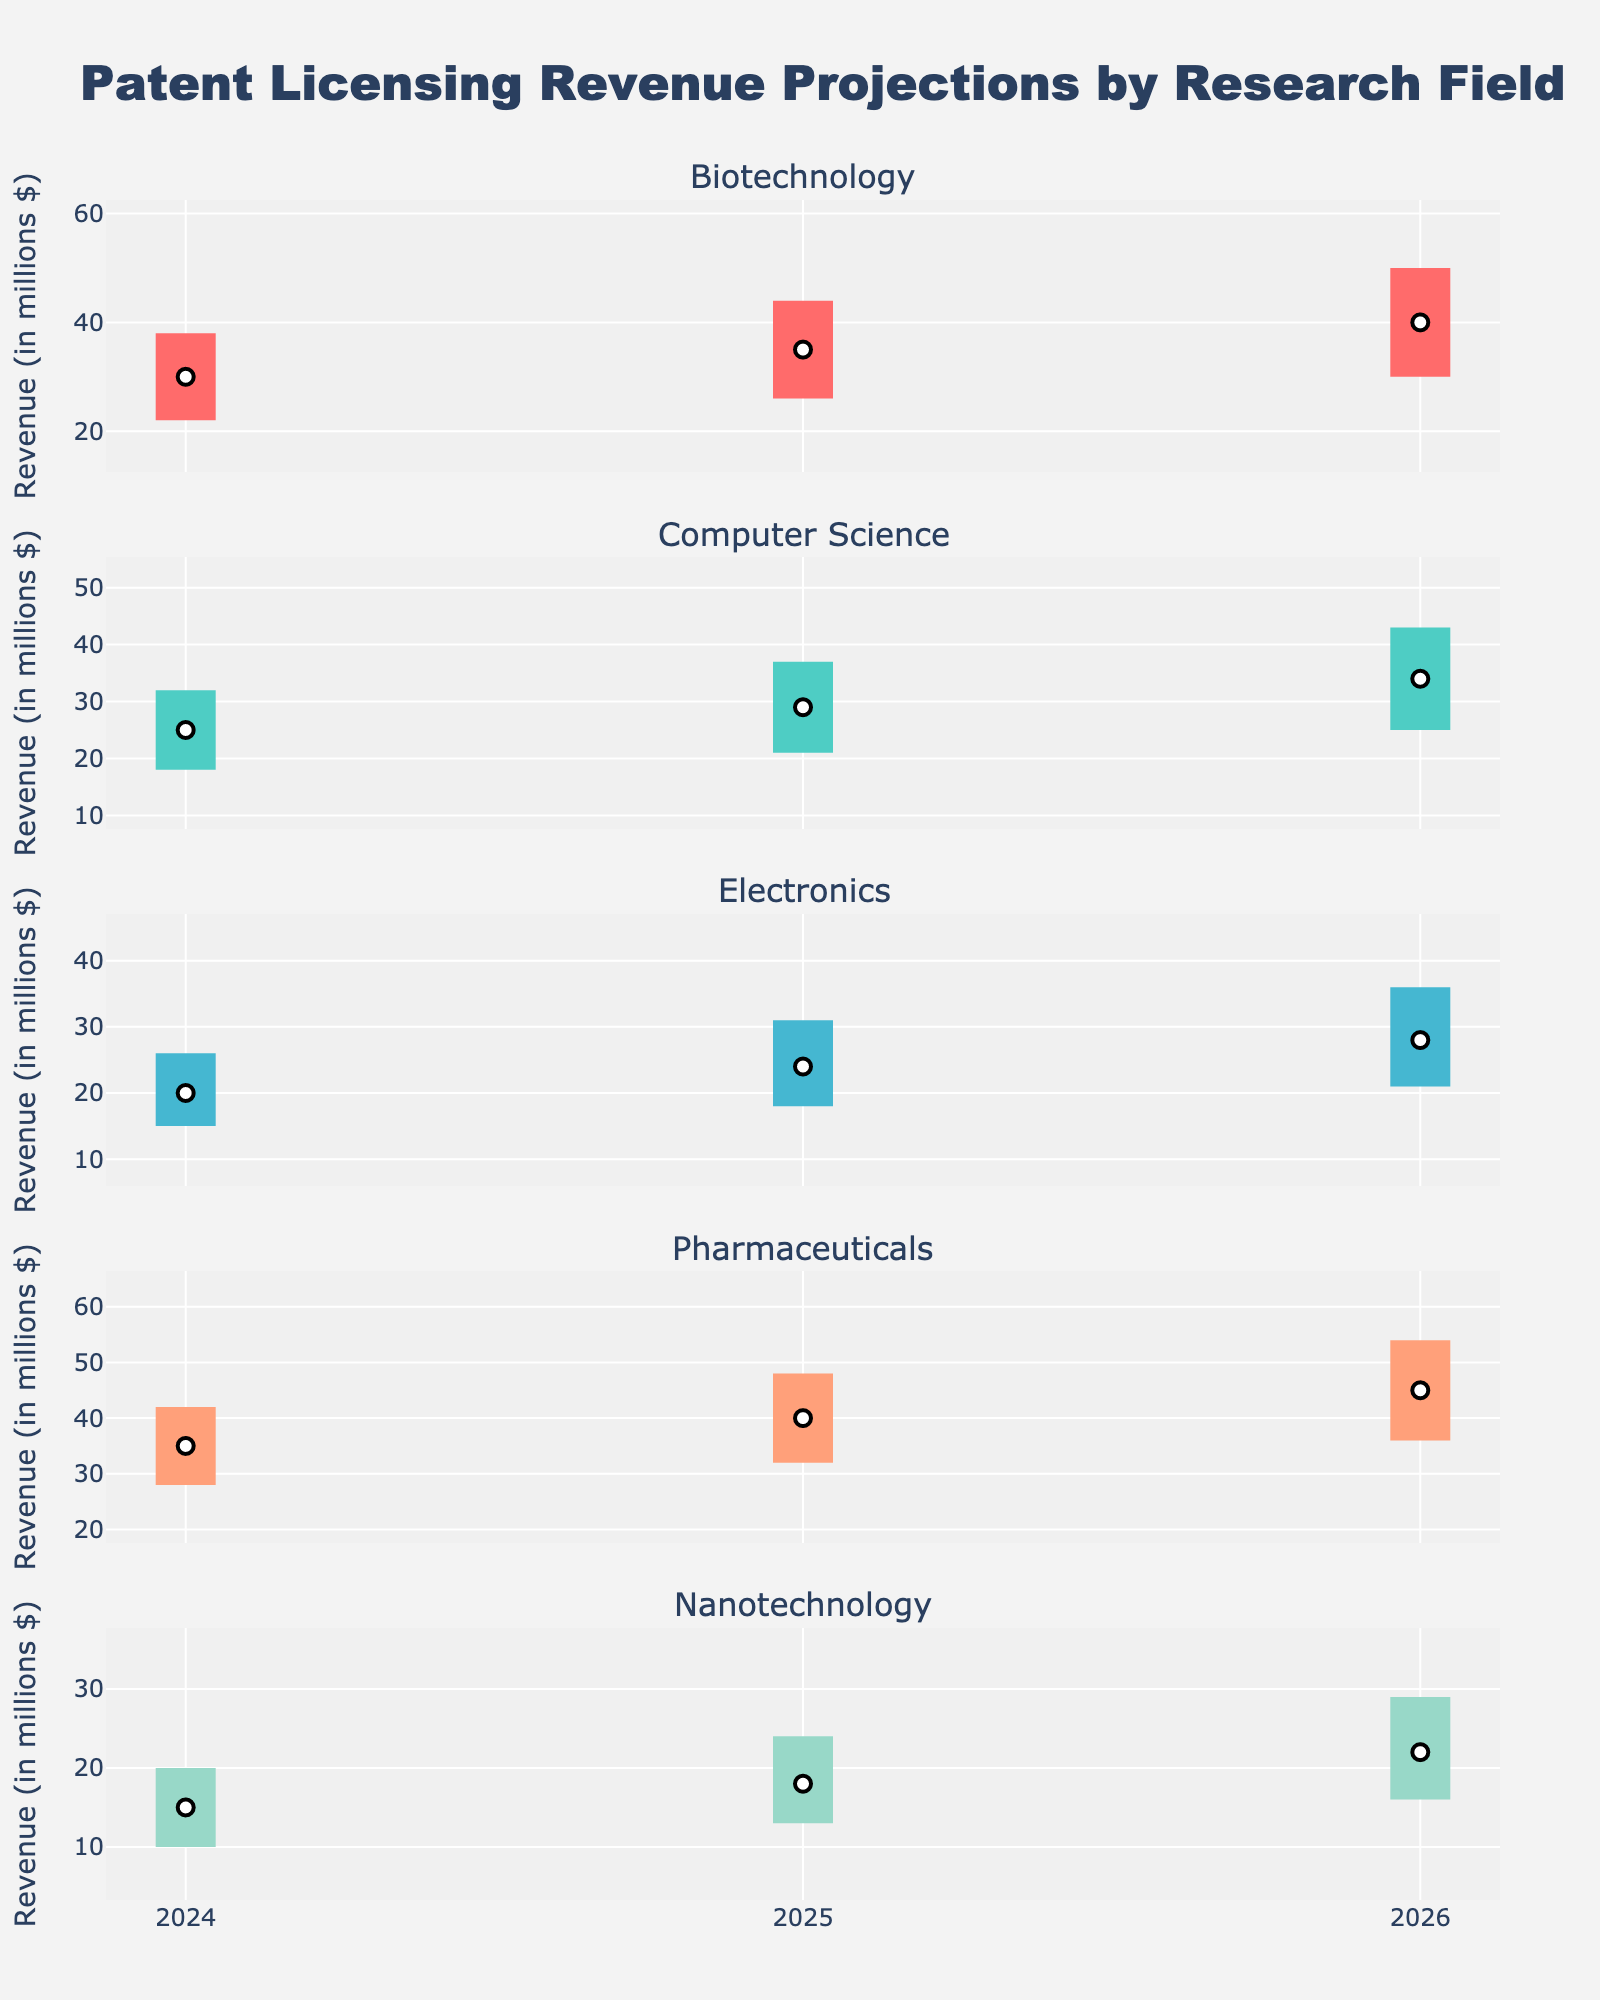What is the title of the chart? The title of the chart is located at the top and reads "Patent Licensing Revenue Projections by Research Field".
Answer: Patent Licensing Revenue Projections by Research Field Which field shows the highest median revenue projection for 2026? Look at the 2026 projections for each field. The median revenue projection is marked by a white marker in each subplot. Identify the highest marker among Biotechnology, Computer Science, Electronics, Pharmaceuticals, and Nanotechnology.
Answer: Pharmaceuticals What is the range of expected revenue for Biotechnology in 2025? For each year, revenue ranges are shown by colored areas. For 2025 in Biotechnology, look at the start and end of the colored area (between P25 and P75) in the Biotechnology subplot. This represents the range.
Answer: 26 to 44 million Which research field shows the smallest difference between the 10th and 90th percentiles in 2024? Examine the difference between the P10 and P90 markers for each field in 2024. Subtract P10 values from P90 values for Biotechnology, Computer Science, Electronics, Pharmaceuticals, and Nanotechnology. Identify the smallest difference.
Answer: Nanotechnology What is the average median revenue projection for all fields in 2025? Identify the median values for each field in 2025 from the white markers: Biotechnology (35), Computer Science (29), Electronics (24), Pharmaceuticals (40), and Nanotechnology (18). Sum these values and divide by the number of fields.
Answer: 29.2 million Which field shows the fastest growth in median revenue projections from 2024 to 2026? Compare the increase in median projections (white markers) from 2024 to 2026 for each field. Calculate the difference for each: Biotechnology (40-30), Computer Science (34-25), Electronics (28-20), Pharmaceuticals (45-35), Nanotechnology (22-15). Identify the largest increase.
Answer: Biotechnology In 2026, do any fields have the same expected revenue range as another? Look at the colored areas representing P25 to P75 ranges in 2026 for each field. Compare the ranges visually to see if any two fields overlap completely.
Answer: No Which field shows the most conservative projection (lowest upper bound) for 2024 across all percentiles? Look at the P90 values (markers for the upper bound) for each field in 2024. Identify the smallest value among Biotechnology, Computer Science, Electronics, Pharmaceuticals, and Nanotechnology.
Answer: Nanotechnology 